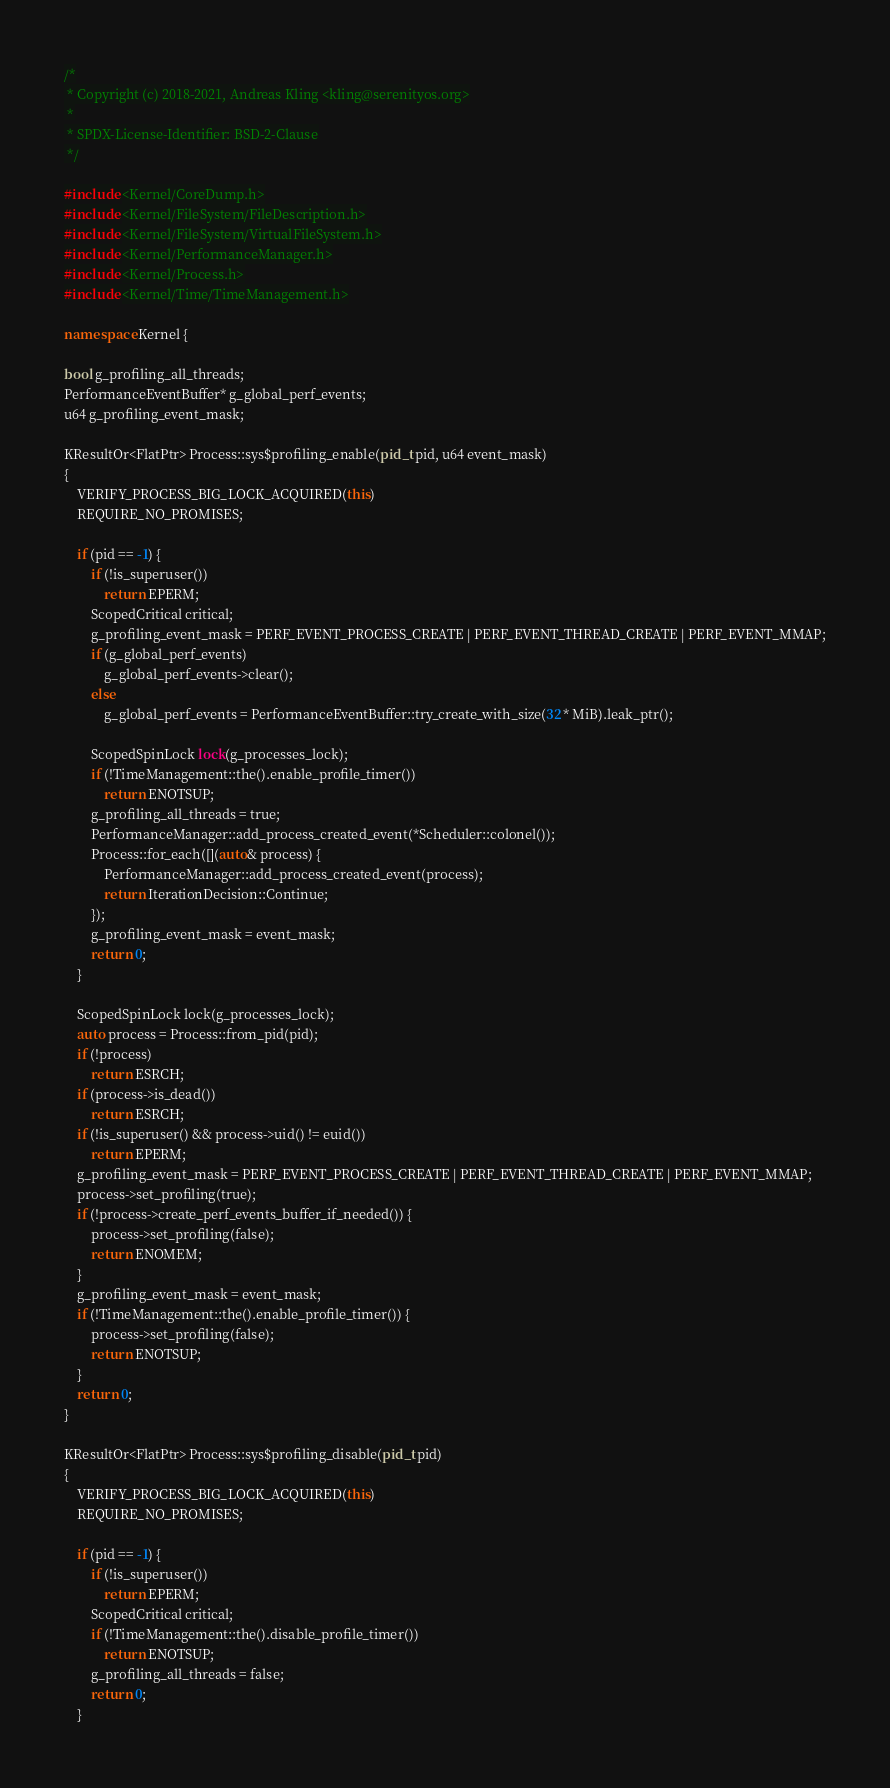<code> <loc_0><loc_0><loc_500><loc_500><_C++_>/*
 * Copyright (c) 2018-2021, Andreas Kling <kling@serenityos.org>
 *
 * SPDX-License-Identifier: BSD-2-Clause
 */

#include <Kernel/CoreDump.h>
#include <Kernel/FileSystem/FileDescription.h>
#include <Kernel/FileSystem/VirtualFileSystem.h>
#include <Kernel/PerformanceManager.h>
#include <Kernel/Process.h>
#include <Kernel/Time/TimeManagement.h>

namespace Kernel {

bool g_profiling_all_threads;
PerformanceEventBuffer* g_global_perf_events;
u64 g_profiling_event_mask;

KResultOr<FlatPtr> Process::sys$profiling_enable(pid_t pid, u64 event_mask)
{
    VERIFY_PROCESS_BIG_LOCK_ACQUIRED(this)
    REQUIRE_NO_PROMISES;

    if (pid == -1) {
        if (!is_superuser())
            return EPERM;
        ScopedCritical critical;
        g_profiling_event_mask = PERF_EVENT_PROCESS_CREATE | PERF_EVENT_THREAD_CREATE | PERF_EVENT_MMAP;
        if (g_global_perf_events)
            g_global_perf_events->clear();
        else
            g_global_perf_events = PerformanceEventBuffer::try_create_with_size(32 * MiB).leak_ptr();

        ScopedSpinLock lock(g_processes_lock);
        if (!TimeManagement::the().enable_profile_timer())
            return ENOTSUP;
        g_profiling_all_threads = true;
        PerformanceManager::add_process_created_event(*Scheduler::colonel());
        Process::for_each([](auto& process) {
            PerformanceManager::add_process_created_event(process);
            return IterationDecision::Continue;
        });
        g_profiling_event_mask = event_mask;
        return 0;
    }

    ScopedSpinLock lock(g_processes_lock);
    auto process = Process::from_pid(pid);
    if (!process)
        return ESRCH;
    if (process->is_dead())
        return ESRCH;
    if (!is_superuser() && process->uid() != euid())
        return EPERM;
    g_profiling_event_mask = PERF_EVENT_PROCESS_CREATE | PERF_EVENT_THREAD_CREATE | PERF_EVENT_MMAP;
    process->set_profiling(true);
    if (!process->create_perf_events_buffer_if_needed()) {
        process->set_profiling(false);
        return ENOMEM;
    }
    g_profiling_event_mask = event_mask;
    if (!TimeManagement::the().enable_profile_timer()) {
        process->set_profiling(false);
        return ENOTSUP;
    }
    return 0;
}

KResultOr<FlatPtr> Process::sys$profiling_disable(pid_t pid)
{
    VERIFY_PROCESS_BIG_LOCK_ACQUIRED(this)
    REQUIRE_NO_PROMISES;

    if (pid == -1) {
        if (!is_superuser())
            return EPERM;
        ScopedCritical critical;
        if (!TimeManagement::the().disable_profile_timer())
            return ENOTSUP;
        g_profiling_all_threads = false;
        return 0;
    }
</code> 